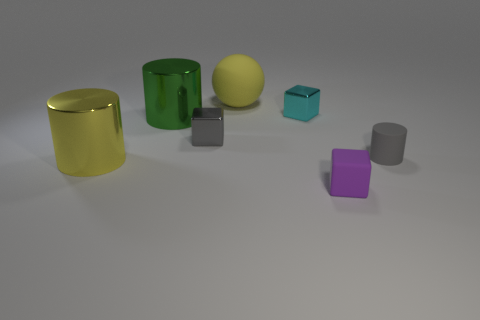Subtract all yellow cylinders. How many cylinders are left? 2 Subtract all purple cubes. How many cubes are left? 2 Subtract all balls. How many objects are left? 6 Add 2 large blue cylinders. How many objects exist? 9 Subtract 3 cylinders. How many cylinders are left? 0 Subtract all yellow cylinders. How many cyan cubes are left? 1 Subtract all large yellow spheres. Subtract all gray metallic cylinders. How many objects are left? 6 Add 1 green metal objects. How many green metal objects are left? 2 Add 2 small green rubber objects. How many small green rubber objects exist? 2 Subtract 0 red spheres. How many objects are left? 7 